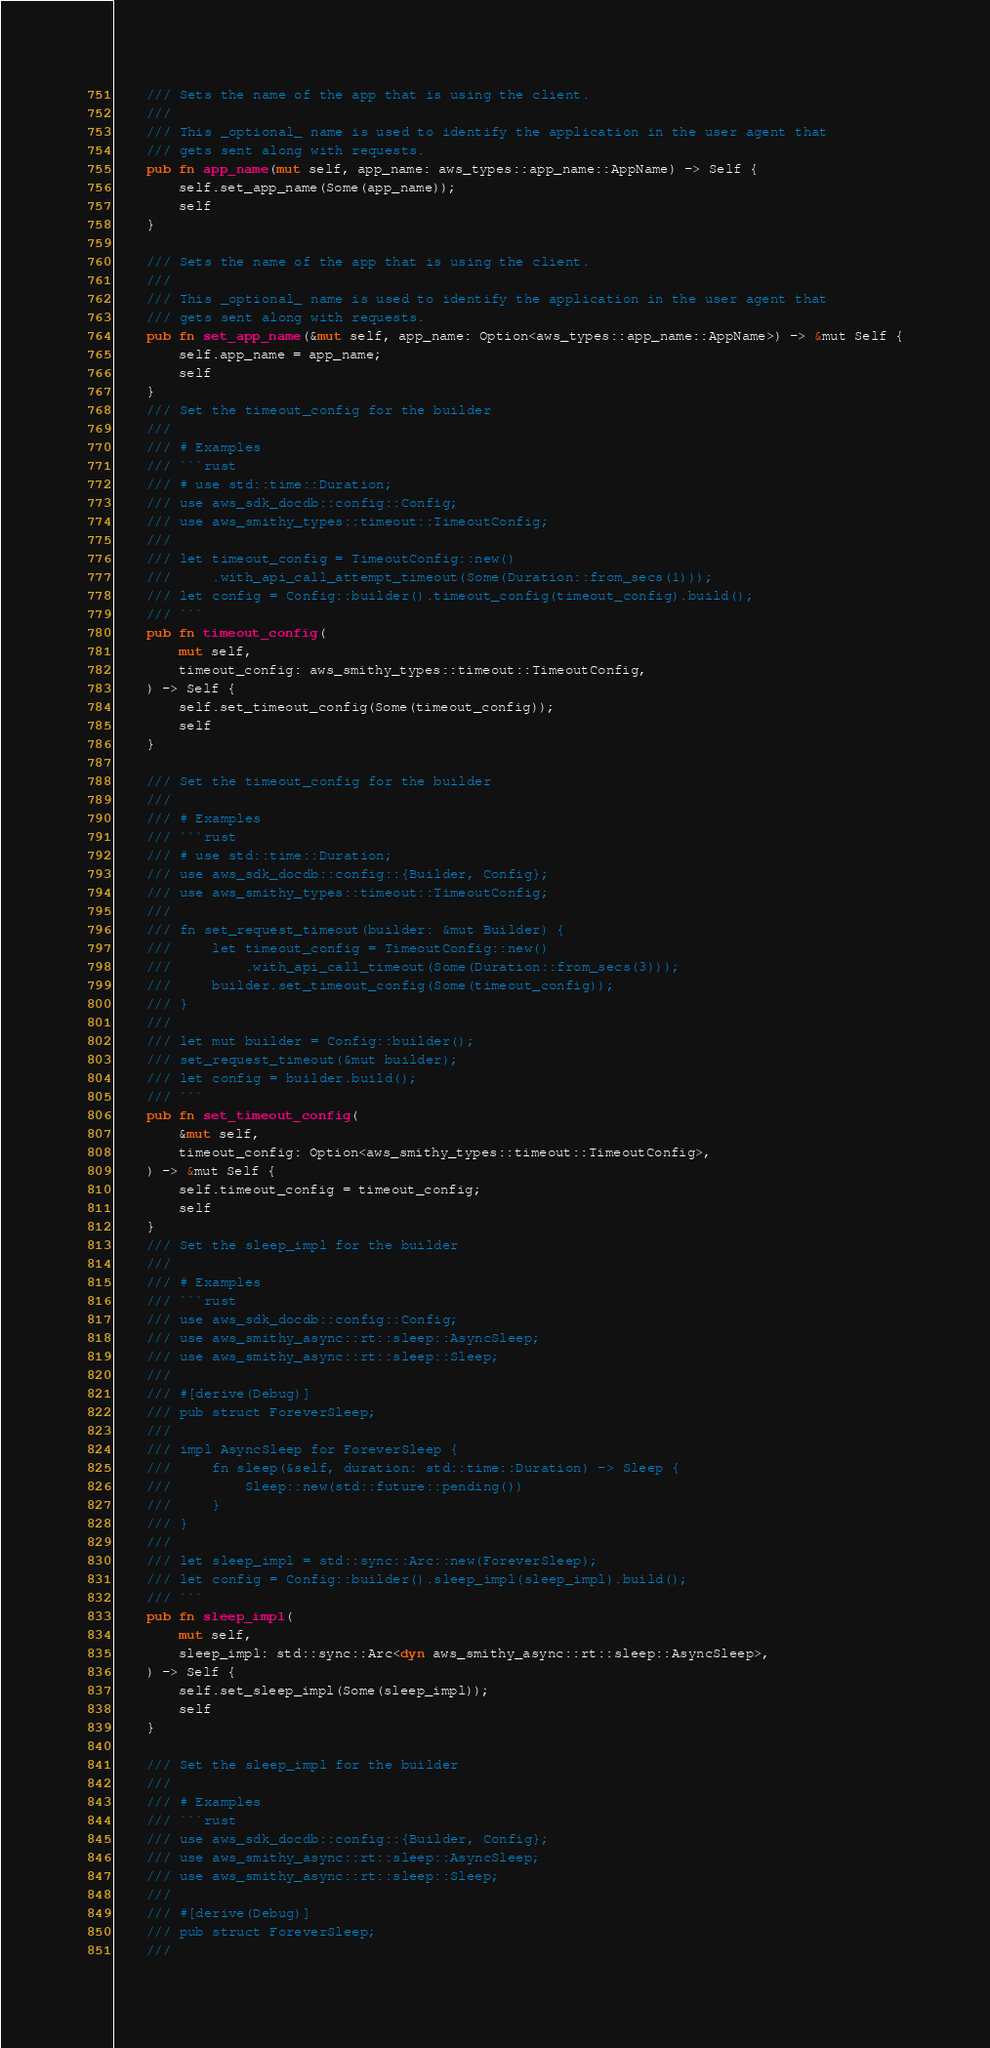Convert code to text. <code><loc_0><loc_0><loc_500><loc_500><_Rust_>    /// Sets the name of the app that is using the client.
    ///
    /// This _optional_ name is used to identify the application in the user agent that
    /// gets sent along with requests.
    pub fn app_name(mut self, app_name: aws_types::app_name::AppName) -> Self {
        self.set_app_name(Some(app_name));
        self
    }

    /// Sets the name of the app that is using the client.
    ///
    /// This _optional_ name is used to identify the application in the user agent that
    /// gets sent along with requests.
    pub fn set_app_name(&mut self, app_name: Option<aws_types::app_name::AppName>) -> &mut Self {
        self.app_name = app_name;
        self
    }
    /// Set the timeout_config for the builder
    ///
    /// # Examples
    /// ```rust
    /// # use std::time::Duration;
    /// use aws_sdk_docdb::config::Config;
    /// use aws_smithy_types::timeout::TimeoutConfig;
    ///
    /// let timeout_config = TimeoutConfig::new()
    ///     .with_api_call_attempt_timeout(Some(Duration::from_secs(1)));
    /// let config = Config::builder().timeout_config(timeout_config).build();
    /// ```
    pub fn timeout_config(
        mut self,
        timeout_config: aws_smithy_types::timeout::TimeoutConfig,
    ) -> Self {
        self.set_timeout_config(Some(timeout_config));
        self
    }

    /// Set the timeout_config for the builder
    ///
    /// # Examples
    /// ```rust
    /// # use std::time::Duration;
    /// use aws_sdk_docdb::config::{Builder, Config};
    /// use aws_smithy_types::timeout::TimeoutConfig;
    ///
    /// fn set_request_timeout(builder: &mut Builder) {
    ///     let timeout_config = TimeoutConfig::new()
    ///         .with_api_call_timeout(Some(Duration::from_secs(3)));
    ///     builder.set_timeout_config(Some(timeout_config));
    /// }
    ///
    /// let mut builder = Config::builder();
    /// set_request_timeout(&mut builder);
    /// let config = builder.build();
    /// ```
    pub fn set_timeout_config(
        &mut self,
        timeout_config: Option<aws_smithy_types::timeout::TimeoutConfig>,
    ) -> &mut Self {
        self.timeout_config = timeout_config;
        self
    }
    /// Set the sleep_impl for the builder
    ///
    /// # Examples
    /// ```rust
    /// use aws_sdk_docdb::config::Config;
    /// use aws_smithy_async::rt::sleep::AsyncSleep;
    /// use aws_smithy_async::rt::sleep::Sleep;
    ///
    /// #[derive(Debug)]
    /// pub struct ForeverSleep;
    ///
    /// impl AsyncSleep for ForeverSleep {
    ///     fn sleep(&self, duration: std::time::Duration) -> Sleep {
    ///         Sleep::new(std::future::pending())
    ///     }
    /// }
    ///
    /// let sleep_impl = std::sync::Arc::new(ForeverSleep);
    /// let config = Config::builder().sleep_impl(sleep_impl).build();
    /// ```
    pub fn sleep_impl(
        mut self,
        sleep_impl: std::sync::Arc<dyn aws_smithy_async::rt::sleep::AsyncSleep>,
    ) -> Self {
        self.set_sleep_impl(Some(sleep_impl));
        self
    }

    /// Set the sleep_impl for the builder
    ///
    /// # Examples
    /// ```rust
    /// use aws_sdk_docdb::config::{Builder, Config};
    /// use aws_smithy_async::rt::sleep::AsyncSleep;
    /// use aws_smithy_async::rt::sleep::Sleep;
    ///
    /// #[derive(Debug)]
    /// pub struct ForeverSleep;
    ///</code> 